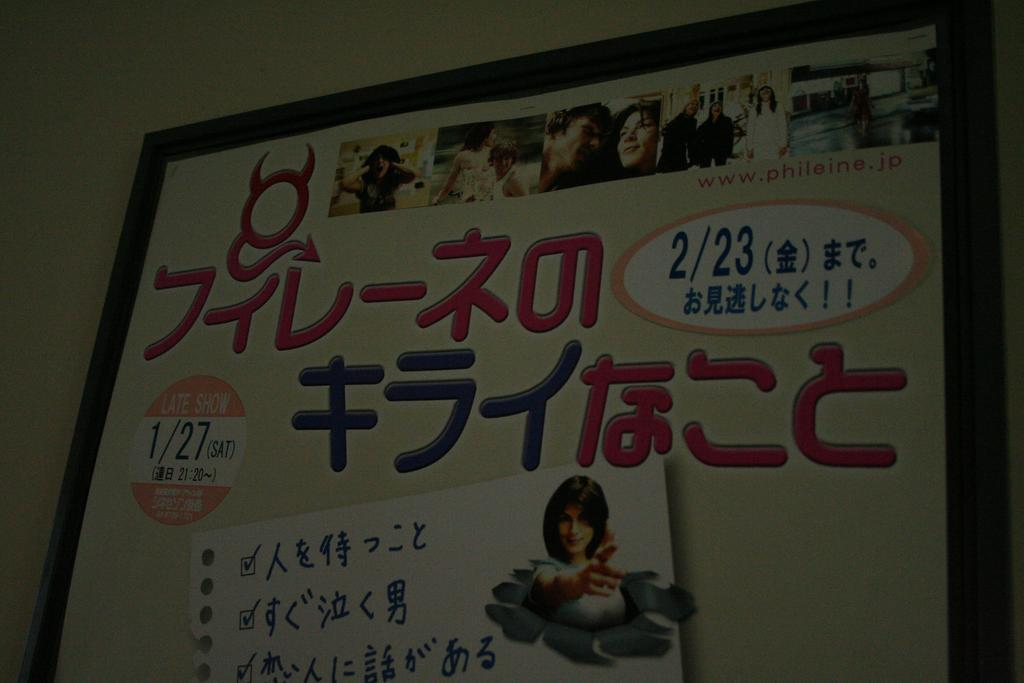What is present on the wall in the image? There is a huge board attached to the wall. What can be seen on the board? There are pictures of persons on the board. Is there any text on the board? Yes, there is writing on the board. What type of corn is growing on the wall in the image? There is no corn present in the image; it features a wall with a huge board attached to it. 